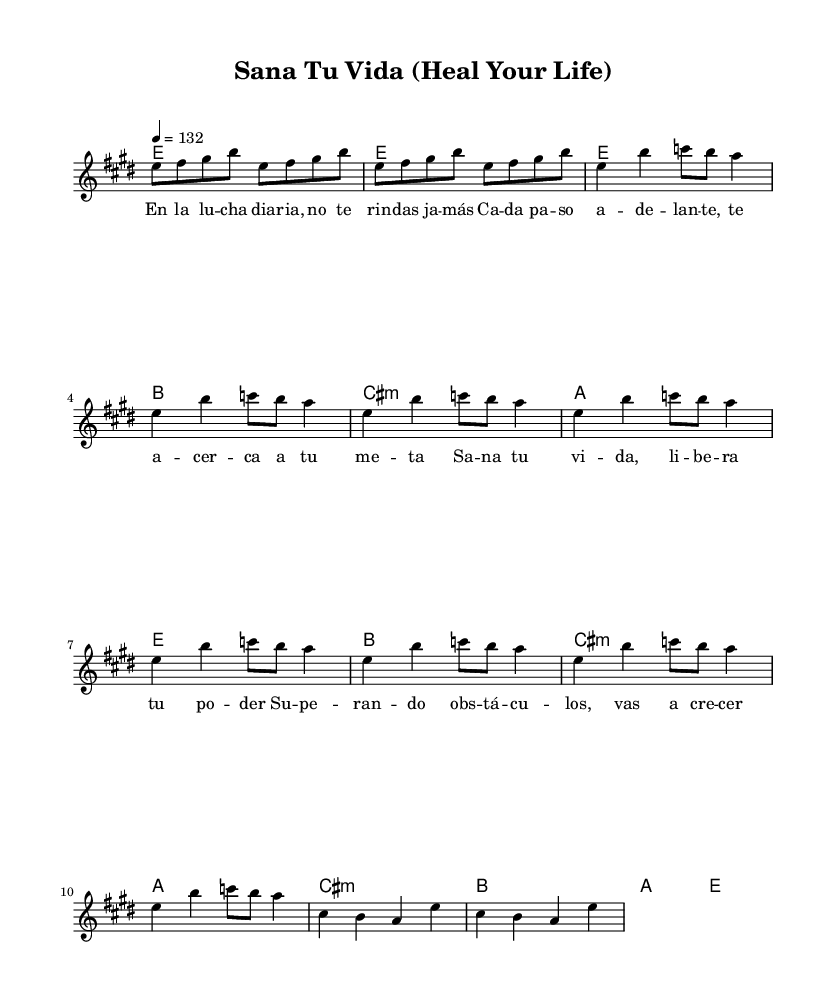What is the key signature of this music? The key signature is E major, which has four sharps (F#, C#, G#, and D#).
Answer: E major What is the time signature of this piece? The time signature is indicated as 4/4, meaning there are four beats in each measure and a quarter note receives one beat.
Answer: 4/4 What is the tempo marking for this music? The tempo marking is indicated as quarter note equals 132 beats per minute, which specifies how fast the music should be played.
Answer: 132 How many measures are there in the chorus? The chorus consists of four measures, as indicated by the notation used for the section.
Answer: 4 What is the primary theme conveyed in the lyrics? The primary theme focuses on healing and personal empowerment, as expressed through phrases in the lyrics.
Answer: Healing and empowerment Which part of the structure includes the bridge? The bridge appears after the chorus and is characterized by a shift in chord progression and melody to create contrast.
Answer: After the chorus What emotion is typically associated with Latin rock anthems like this one? Latin rock anthems often evoke feelings of motivation and resilience, encouraging listeners to overcome challenges.
Answer: Motivation 